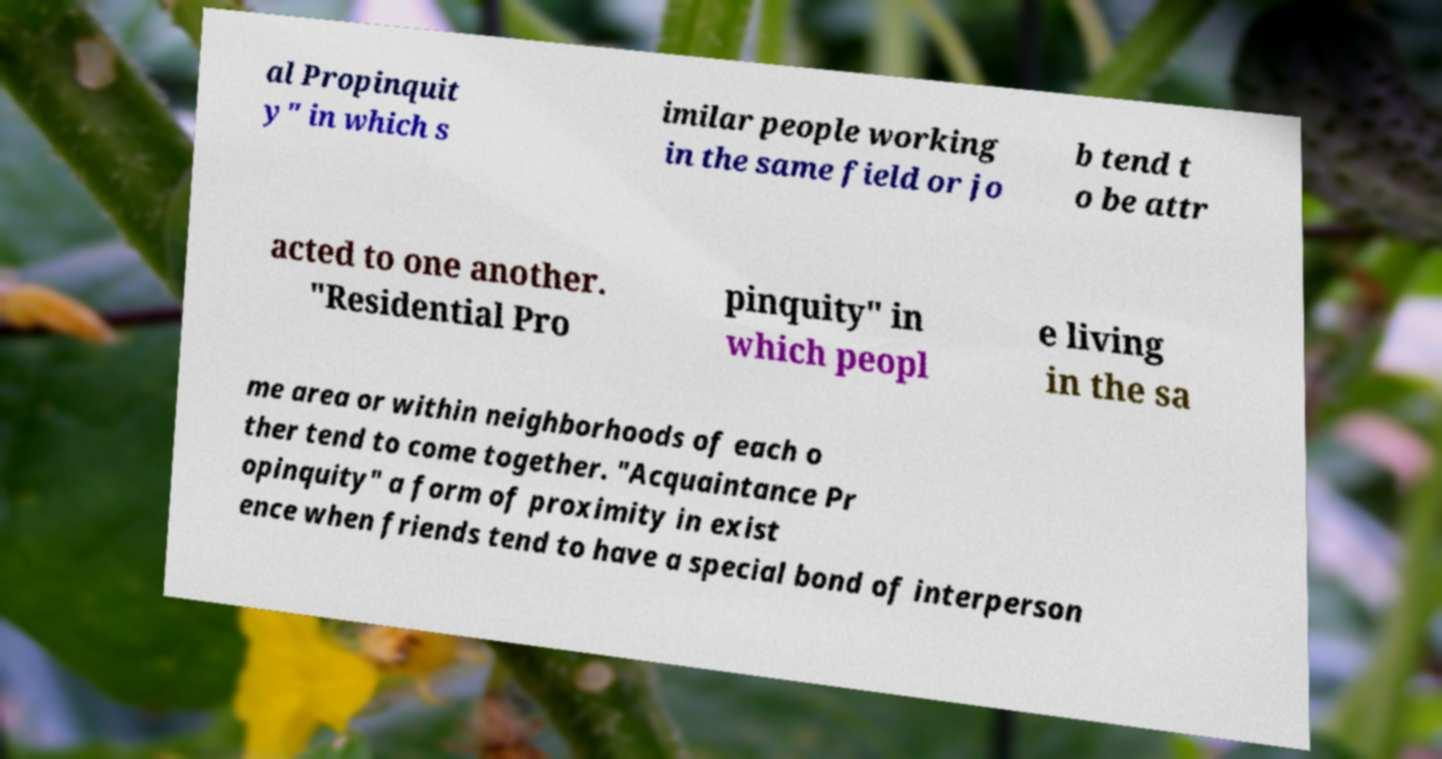Could you extract and type out the text from this image? al Propinquit y" in which s imilar people working in the same field or jo b tend t o be attr acted to one another. "Residential Pro pinquity" in which peopl e living in the sa me area or within neighborhoods of each o ther tend to come together. "Acquaintance Pr opinquity" a form of proximity in exist ence when friends tend to have a special bond of interperson 